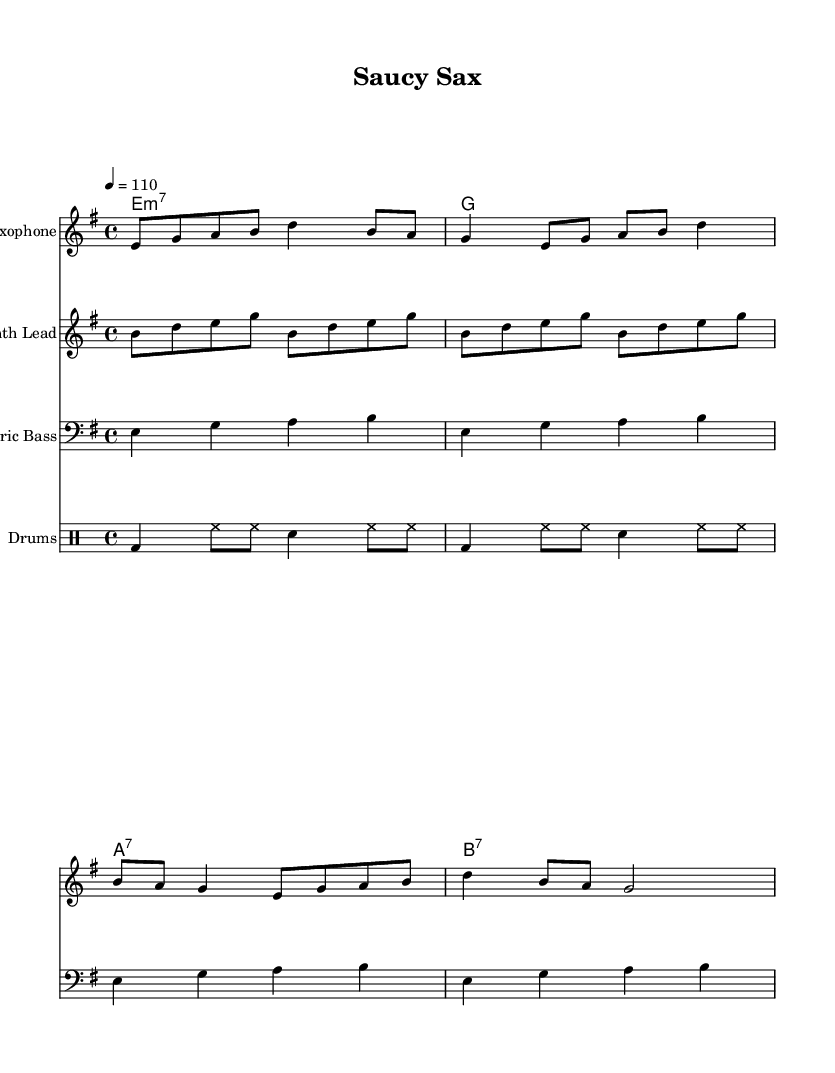What is the key signature of this music? The key signature is E minor, which has one sharp (F#). This is indicated at the beginning of the score.
Answer: E minor What is the time signature of this music? The time signature is 4/4, which is shown at the start of the music. Each measure is divided into four beats.
Answer: 4/4 What is the tempo marking in this piece? The tempo marking is 4 = 110, indicating that there are 110 beats per minute, with a quarter note receiving one beat.
Answer: 110 How many measures does the saxophone melody have? The saxophone melody consists of four measures, as indicated by the grouping of rhythms in the notation before the next section starts.
Answer: Four measures What type of seventh chord is indicated in the electric guitar part? The electric guitar part contains minor seventh chords, specifically indicated by the "m7" notation above the first chord.
Answer: Minor seventh How does the lyric content reflect the funk genre? The lyrics playfully utilize double entendres and have a provocative tone, which is a hallmark of funk music showcasing humor and boldness in themes.
Answer: Provocative tone What instruments are included in this score? The score includes saxophone, electric bass, electric guitar, synth lead, and drums. Each is noted with its respective instrument name at the beginning of the staff.
Answer: Saxophone, electric bass, electric guitar, synth lead, drums 